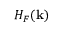Convert formula to latex. <formula><loc_0><loc_0><loc_500><loc_500>H _ { F } ( { k } )</formula> 